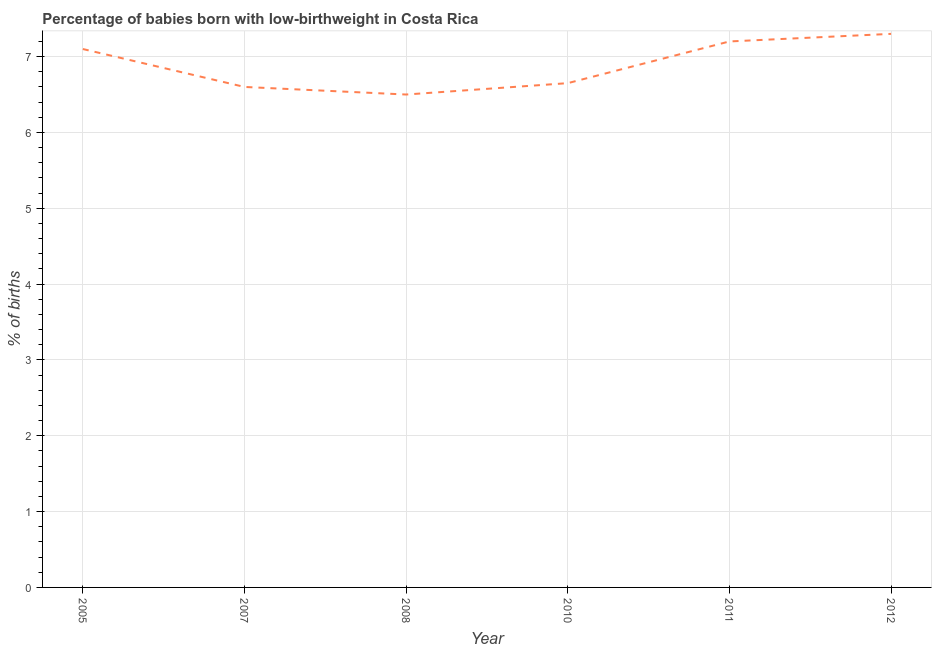Across all years, what is the maximum percentage of babies who were born with low-birthweight?
Keep it short and to the point. 7.3. In which year was the percentage of babies who were born with low-birthweight minimum?
Offer a very short reply. 2008. What is the sum of the percentage of babies who were born with low-birthweight?
Your answer should be very brief. 41.35. What is the difference between the percentage of babies who were born with low-birthweight in 2010 and 2012?
Offer a very short reply. -0.65. What is the average percentage of babies who were born with low-birthweight per year?
Give a very brief answer. 6.89. What is the median percentage of babies who were born with low-birthweight?
Ensure brevity in your answer.  6.88. Do a majority of the years between 2007 and 2008 (inclusive) have percentage of babies who were born with low-birthweight greater than 5.6 %?
Your answer should be compact. Yes. What is the ratio of the percentage of babies who were born with low-birthweight in 2005 to that in 2007?
Ensure brevity in your answer.  1.08. What is the difference between the highest and the second highest percentage of babies who were born with low-birthweight?
Your answer should be compact. 0.1. What is the difference between the highest and the lowest percentage of babies who were born with low-birthweight?
Give a very brief answer. 0.8. Does the percentage of babies who were born with low-birthweight monotonically increase over the years?
Offer a terse response. No. How many lines are there?
Keep it short and to the point. 1. What is the difference between two consecutive major ticks on the Y-axis?
Offer a terse response. 1. Are the values on the major ticks of Y-axis written in scientific E-notation?
Offer a very short reply. No. Does the graph contain grids?
Offer a terse response. Yes. What is the title of the graph?
Ensure brevity in your answer.  Percentage of babies born with low-birthweight in Costa Rica. What is the label or title of the X-axis?
Provide a succinct answer. Year. What is the label or title of the Y-axis?
Provide a short and direct response. % of births. What is the % of births in 2007?
Offer a very short reply. 6.6. What is the % of births in 2010?
Offer a terse response. 6.65. What is the % of births of 2011?
Ensure brevity in your answer.  7.2. What is the difference between the % of births in 2005 and 2010?
Your response must be concise. 0.45. What is the difference between the % of births in 2005 and 2011?
Provide a short and direct response. -0.1. What is the difference between the % of births in 2005 and 2012?
Make the answer very short. -0.2. What is the difference between the % of births in 2007 and 2010?
Give a very brief answer. -0.05. What is the difference between the % of births in 2007 and 2011?
Give a very brief answer. -0.6. What is the difference between the % of births in 2008 and 2010?
Your response must be concise. -0.15. What is the difference between the % of births in 2008 and 2011?
Keep it short and to the point. -0.7. What is the difference between the % of births in 2008 and 2012?
Ensure brevity in your answer.  -0.8. What is the difference between the % of births in 2010 and 2011?
Make the answer very short. -0.55. What is the difference between the % of births in 2010 and 2012?
Your answer should be compact. -0.65. What is the ratio of the % of births in 2005 to that in 2007?
Keep it short and to the point. 1.08. What is the ratio of the % of births in 2005 to that in 2008?
Your answer should be compact. 1.09. What is the ratio of the % of births in 2005 to that in 2010?
Your answer should be compact. 1.07. What is the ratio of the % of births in 2005 to that in 2011?
Offer a very short reply. 0.99. What is the ratio of the % of births in 2005 to that in 2012?
Your answer should be very brief. 0.97. What is the ratio of the % of births in 2007 to that in 2010?
Offer a very short reply. 0.99. What is the ratio of the % of births in 2007 to that in 2011?
Ensure brevity in your answer.  0.92. What is the ratio of the % of births in 2007 to that in 2012?
Give a very brief answer. 0.9. What is the ratio of the % of births in 2008 to that in 2010?
Offer a terse response. 0.98. What is the ratio of the % of births in 2008 to that in 2011?
Your response must be concise. 0.9. What is the ratio of the % of births in 2008 to that in 2012?
Make the answer very short. 0.89. What is the ratio of the % of births in 2010 to that in 2011?
Offer a very short reply. 0.92. What is the ratio of the % of births in 2010 to that in 2012?
Give a very brief answer. 0.91. What is the ratio of the % of births in 2011 to that in 2012?
Your answer should be very brief. 0.99. 